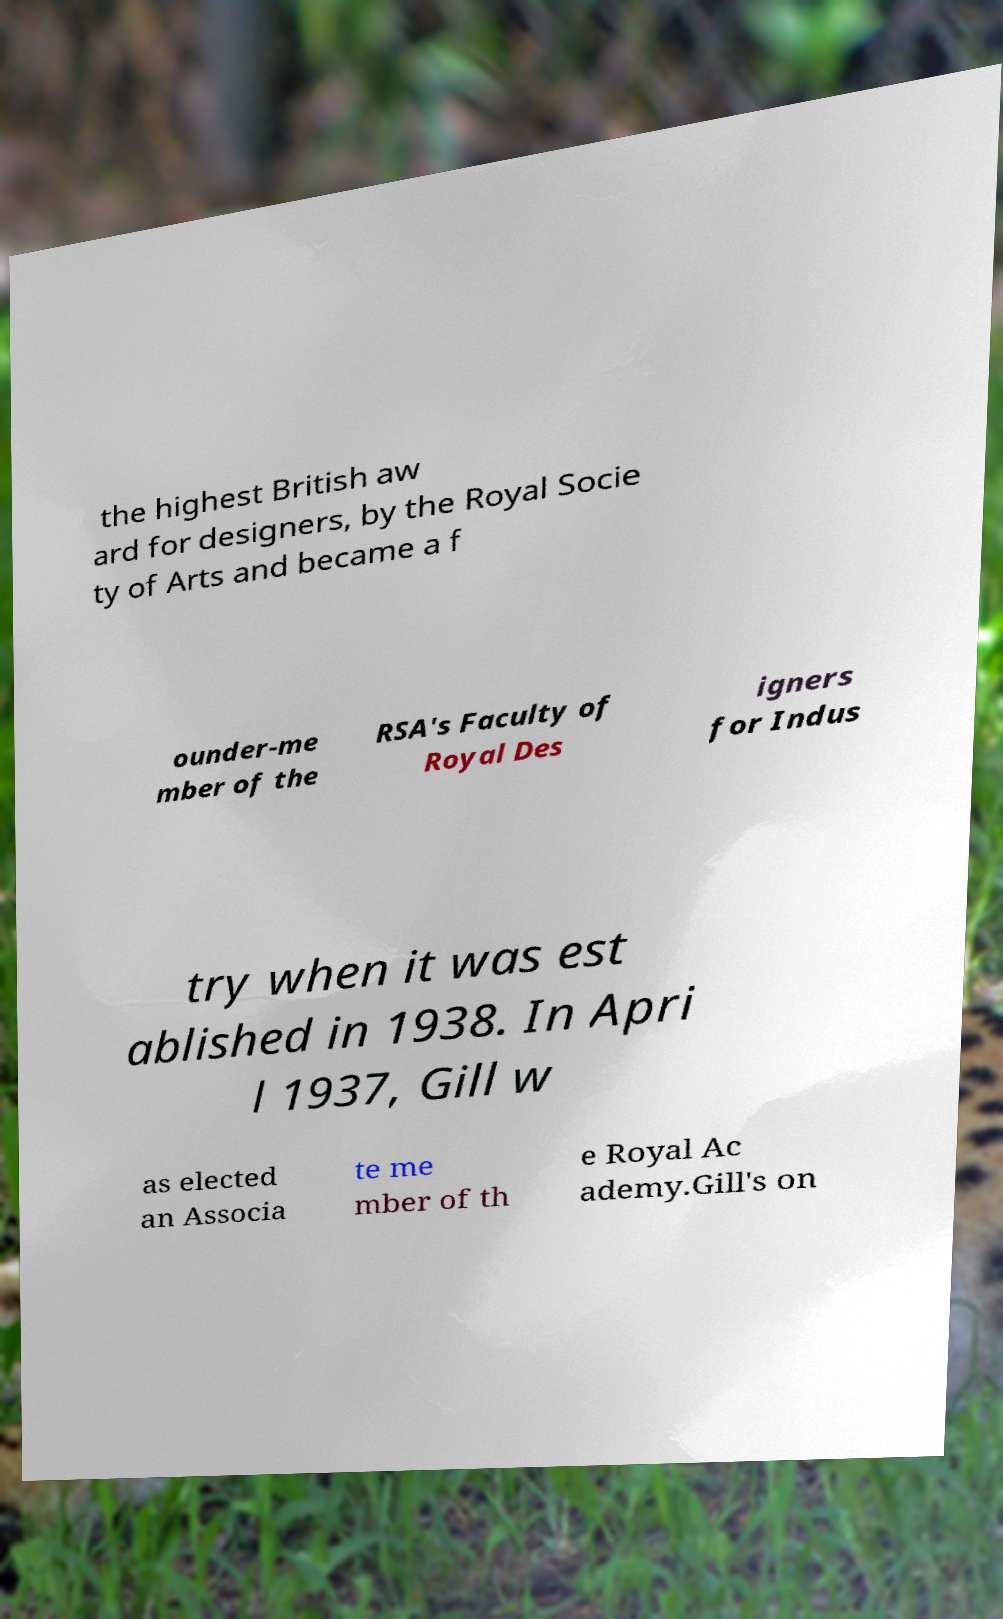Please identify and transcribe the text found in this image. the highest British aw ard for designers, by the Royal Socie ty of Arts and became a f ounder-me mber of the RSA's Faculty of Royal Des igners for Indus try when it was est ablished in 1938. In Apri l 1937, Gill w as elected an Associa te me mber of th e Royal Ac ademy.Gill's on 